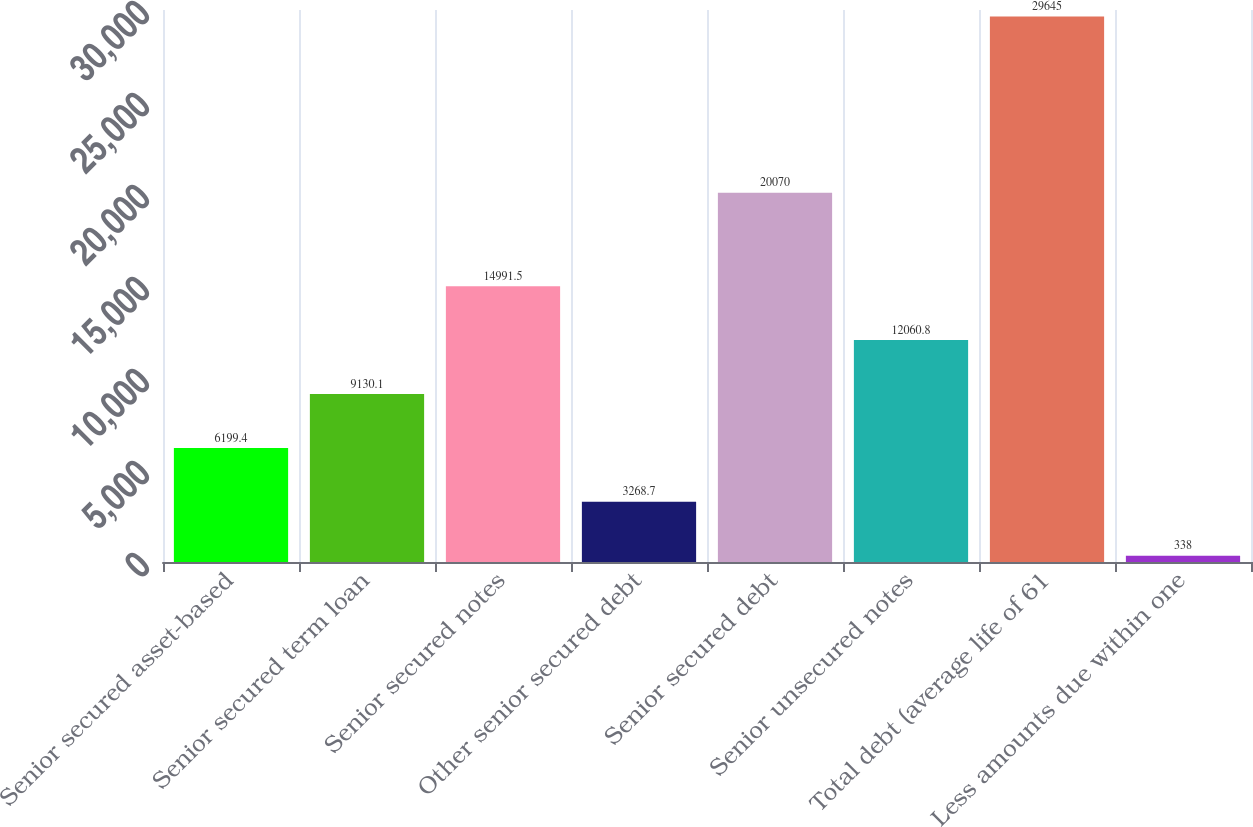<chart> <loc_0><loc_0><loc_500><loc_500><bar_chart><fcel>Senior secured asset-based<fcel>Senior secured term loan<fcel>Senior secured notes<fcel>Other senior secured debt<fcel>Senior secured debt<fcel>Senior unsecured notes<fcel>Total debt (average life of 61<fcel>Less amounts due within one<nl><fcel>6199.4<fcel>9130.1<fcel>14991.5<fcel>3268.7<fcel>20070<fcel>12060.8<fcel>29645<fcel>338<nl></chart> 